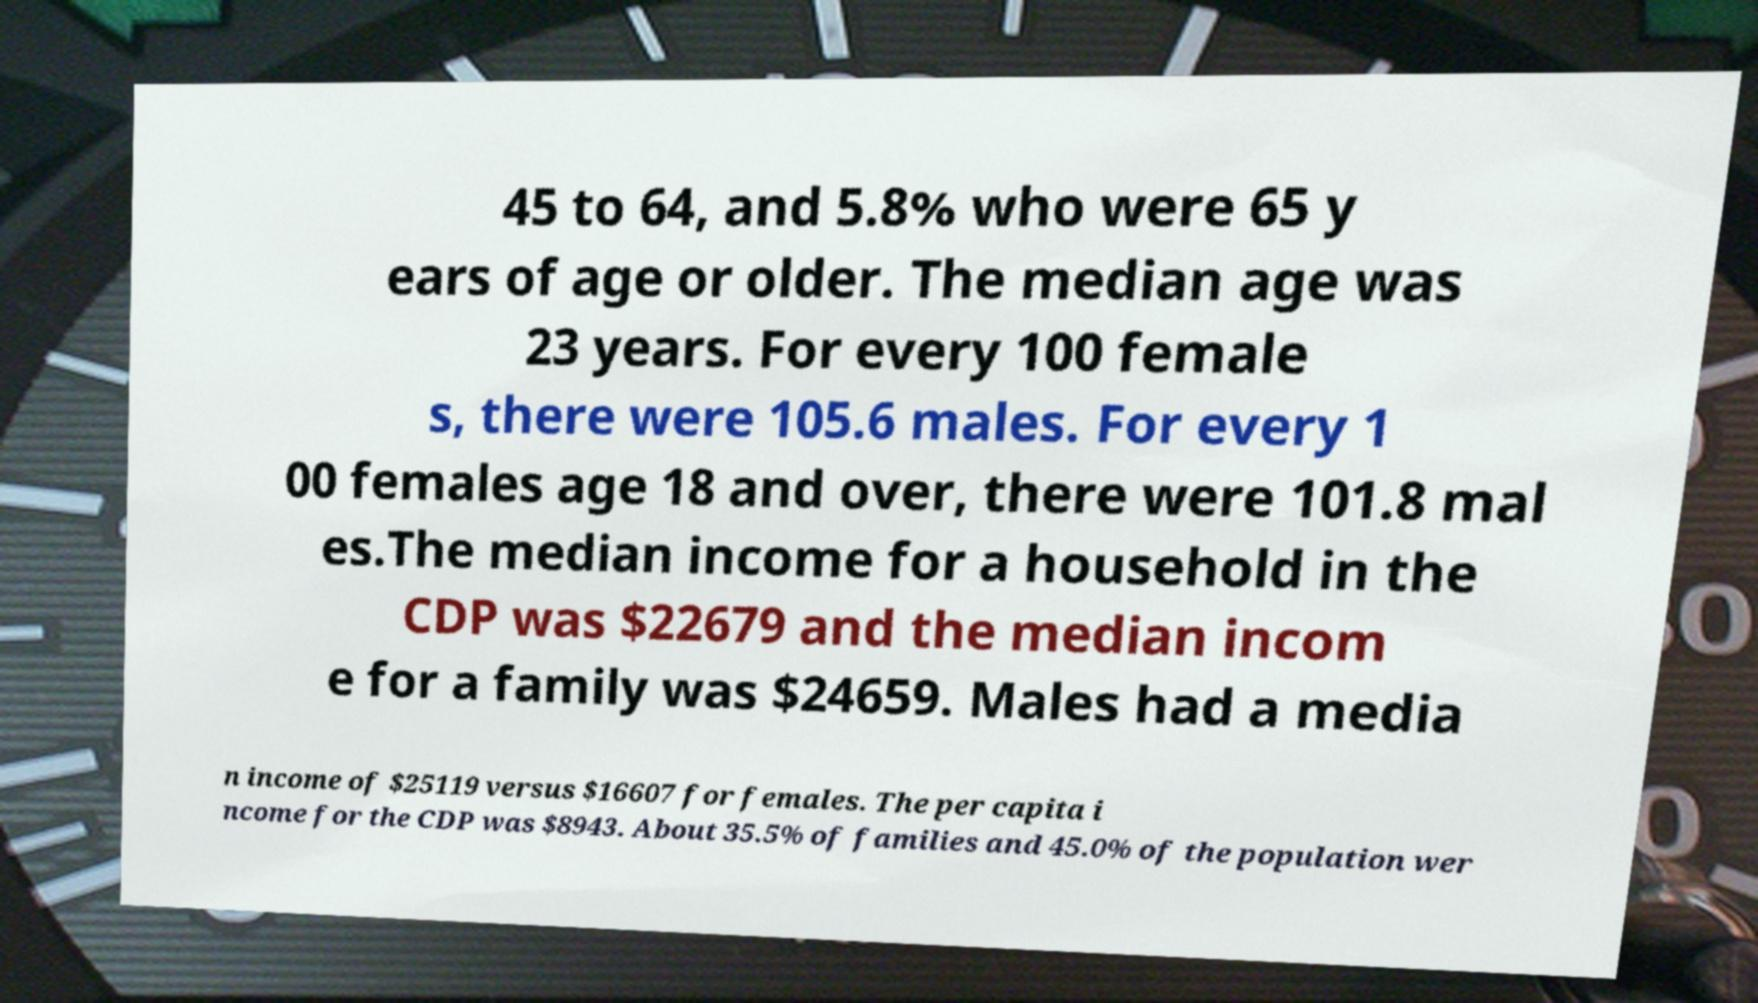For documentation purposes, I need the text within this image transcribed. Could you provide that? 45 to 64, and 5.8% who were 65 y ears of age or older. The median age was 23 years. For every 100 female s, there were 105.6 males. For every 1 00 females age 18 and over, there were 101.8 mal es.The median income for a household in the CDP was $22679 and the median incom e for a family was $24659. Males had a media n income of $25119 versus $16607 for females. The per capita i ncome for the CDP was $8943. About 35.5% of families and 45.0% of the population wer 